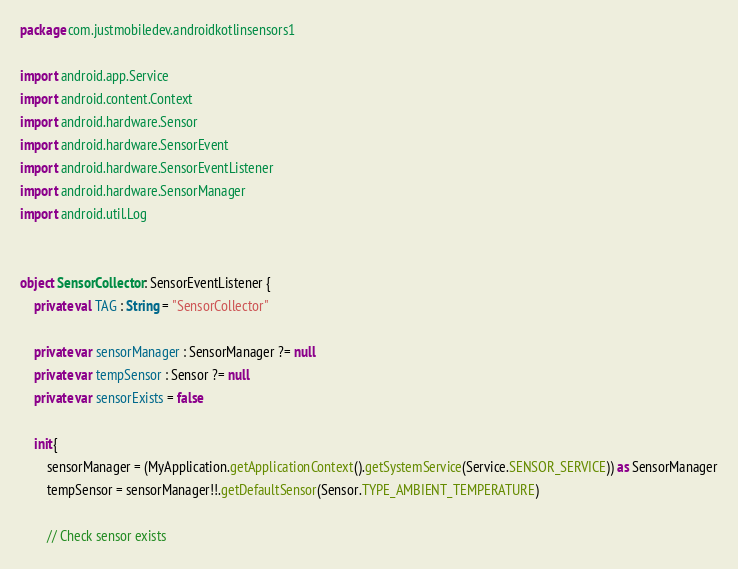<code> <loc_0><loc_0><loc_500><loc_500><_Kotlin_>package com.justmobiledev.androidkotlinsensors1

import android.app.Service
import android.content.Context
import android.hardware.Sensor
import android.hardware.SensorEvent
import android.hardware.SensorEventListener
import android.hardware.SensorManager
import android.util.Log


object SensorCollector: SensorEventListener {
    private val TAG : String = "SensorCollector"

    private var sensorManager : SensorManager ?= null
    private var tempSensor : Sensor ?= null
    private var sensorExists = false

    init{
        sensorManager = (MyApplication.getApplicationContext().getSystemService(Service.SENSOR_SERVICE)) as SensorManager
        tempSensor = sensorManager!!.getDefaultSensor(Sensor.TYPE_AMBIENT_TEMPERATURE)

        // Check sensor exists</code> 